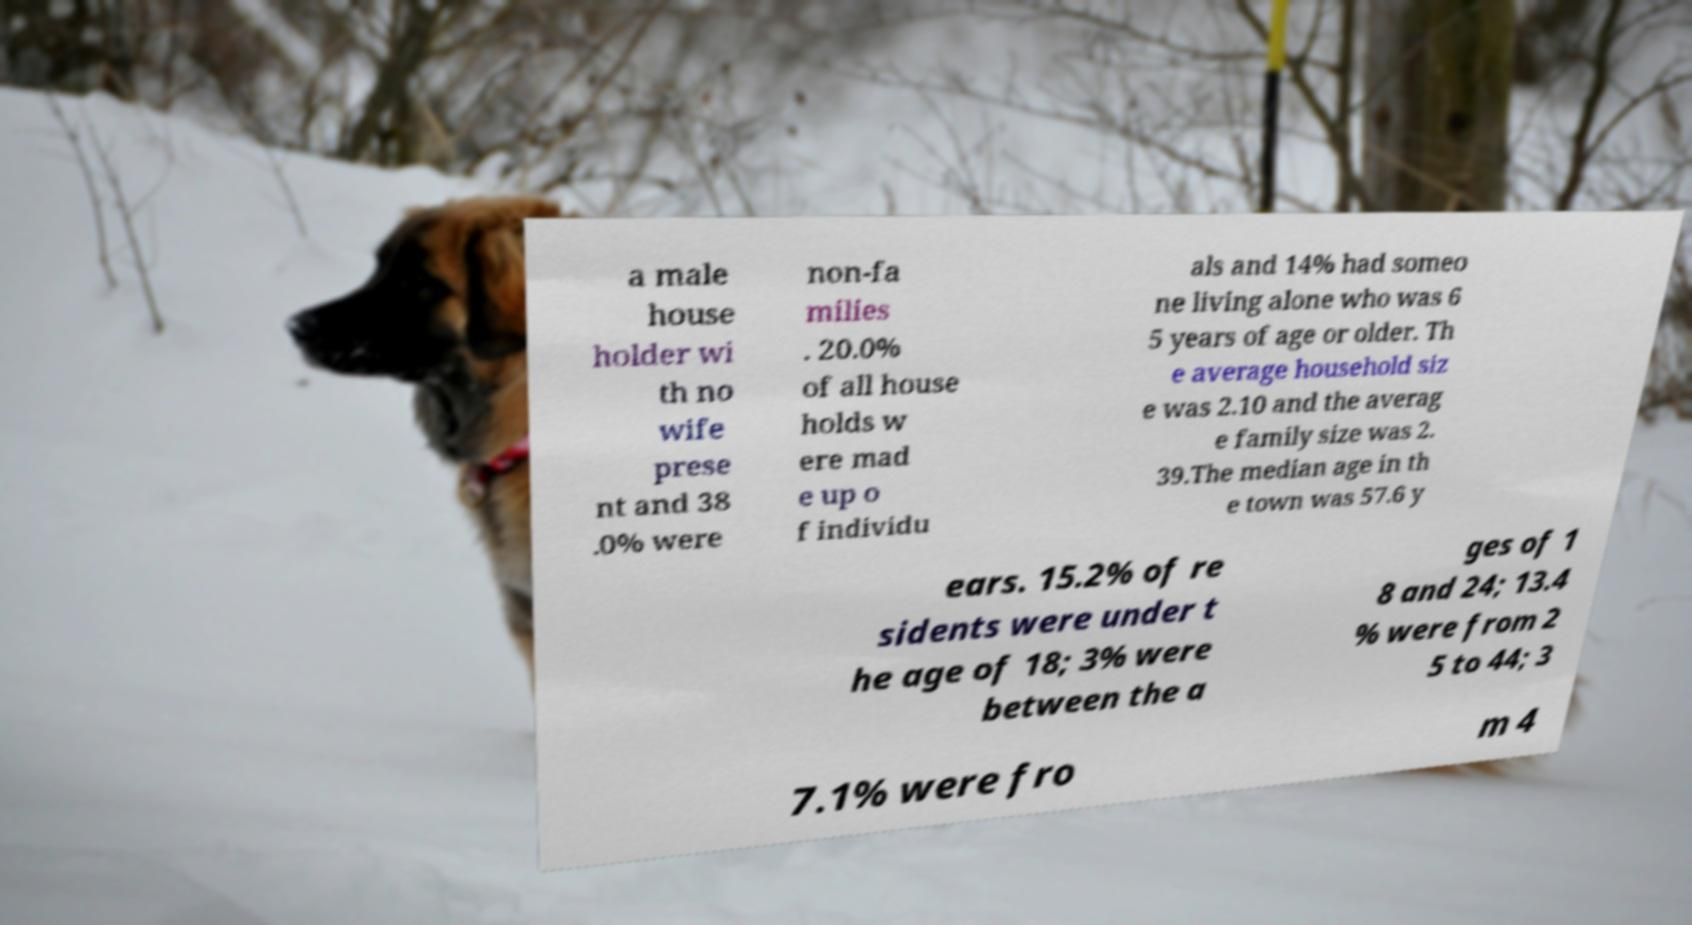What messages or text are displayed in this image? I need them in a readable, typed format. a male house holder wi th no wife prese nt and 38 .0% were non-fa milies . 20.0% of all house holds w ere mad e up o f individu als and 14% had someo ne living alone who was 6 5 years of age or older. Th e average household siz e was 2.10 and the averag e family size was 2. 39.The median age in th e town was 57.6 y ears. 15.2% of re sidents were under t he age of 18; 3% were between the a ges of 1 8 and 24; 13.4 % were from 2 5 to 44; 3 7.1% were fro m 4 